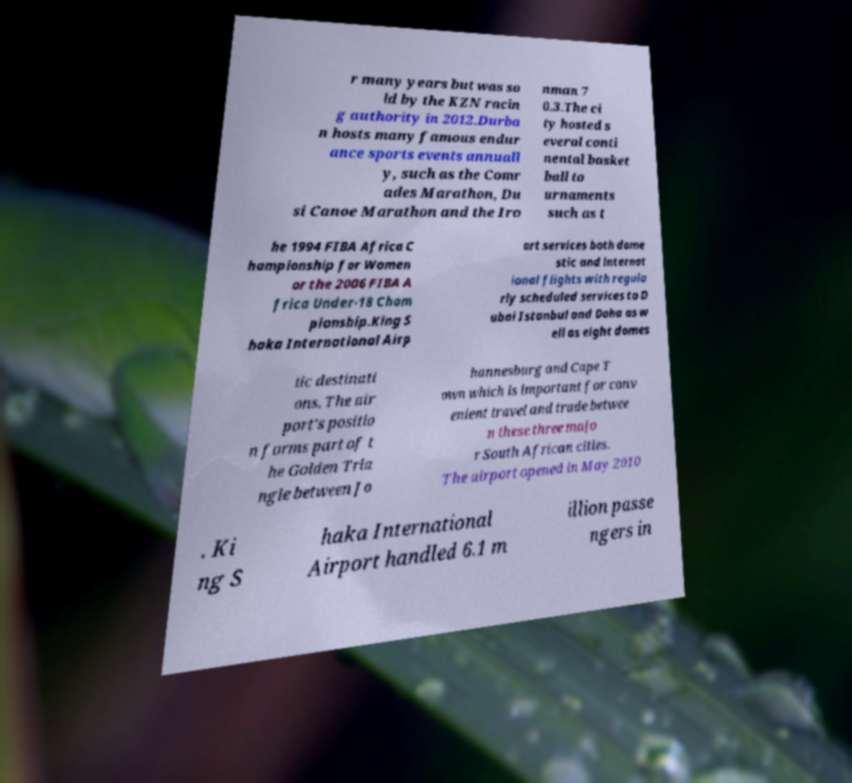Can you accurately transcribe the text from the provided image for me? r many years but was so ld by the KZN racin g authority in 2012.Durba n hosts many famous endur ance sports events annuall y, such as the Comr ades Marathon, Du si Canoe Marathon and the Iro nman 7 0.3.The ci ty hosted s everal conti nental basket ball to urnaments such as t he 1994 FIBA Africa C hampionship for Women or the 2006 FIBA A frica Under-18 Cham pionship.King S haka International Airp ort services both dome stic and internat ional flights with regula rly scheduled services to D ubai Istanbul and Doha as w ell as eight domes tic destinati ons. The air port's positio n forms part of t he Golden Tria ngle between Jo hannesburg and Cape T own which is important for conv enient travel and trade betwee n these three majo r South African cities. The airport opened in May 2010 . Ki ng S haka International Airport handled 6.1 m illion passe ngers in 